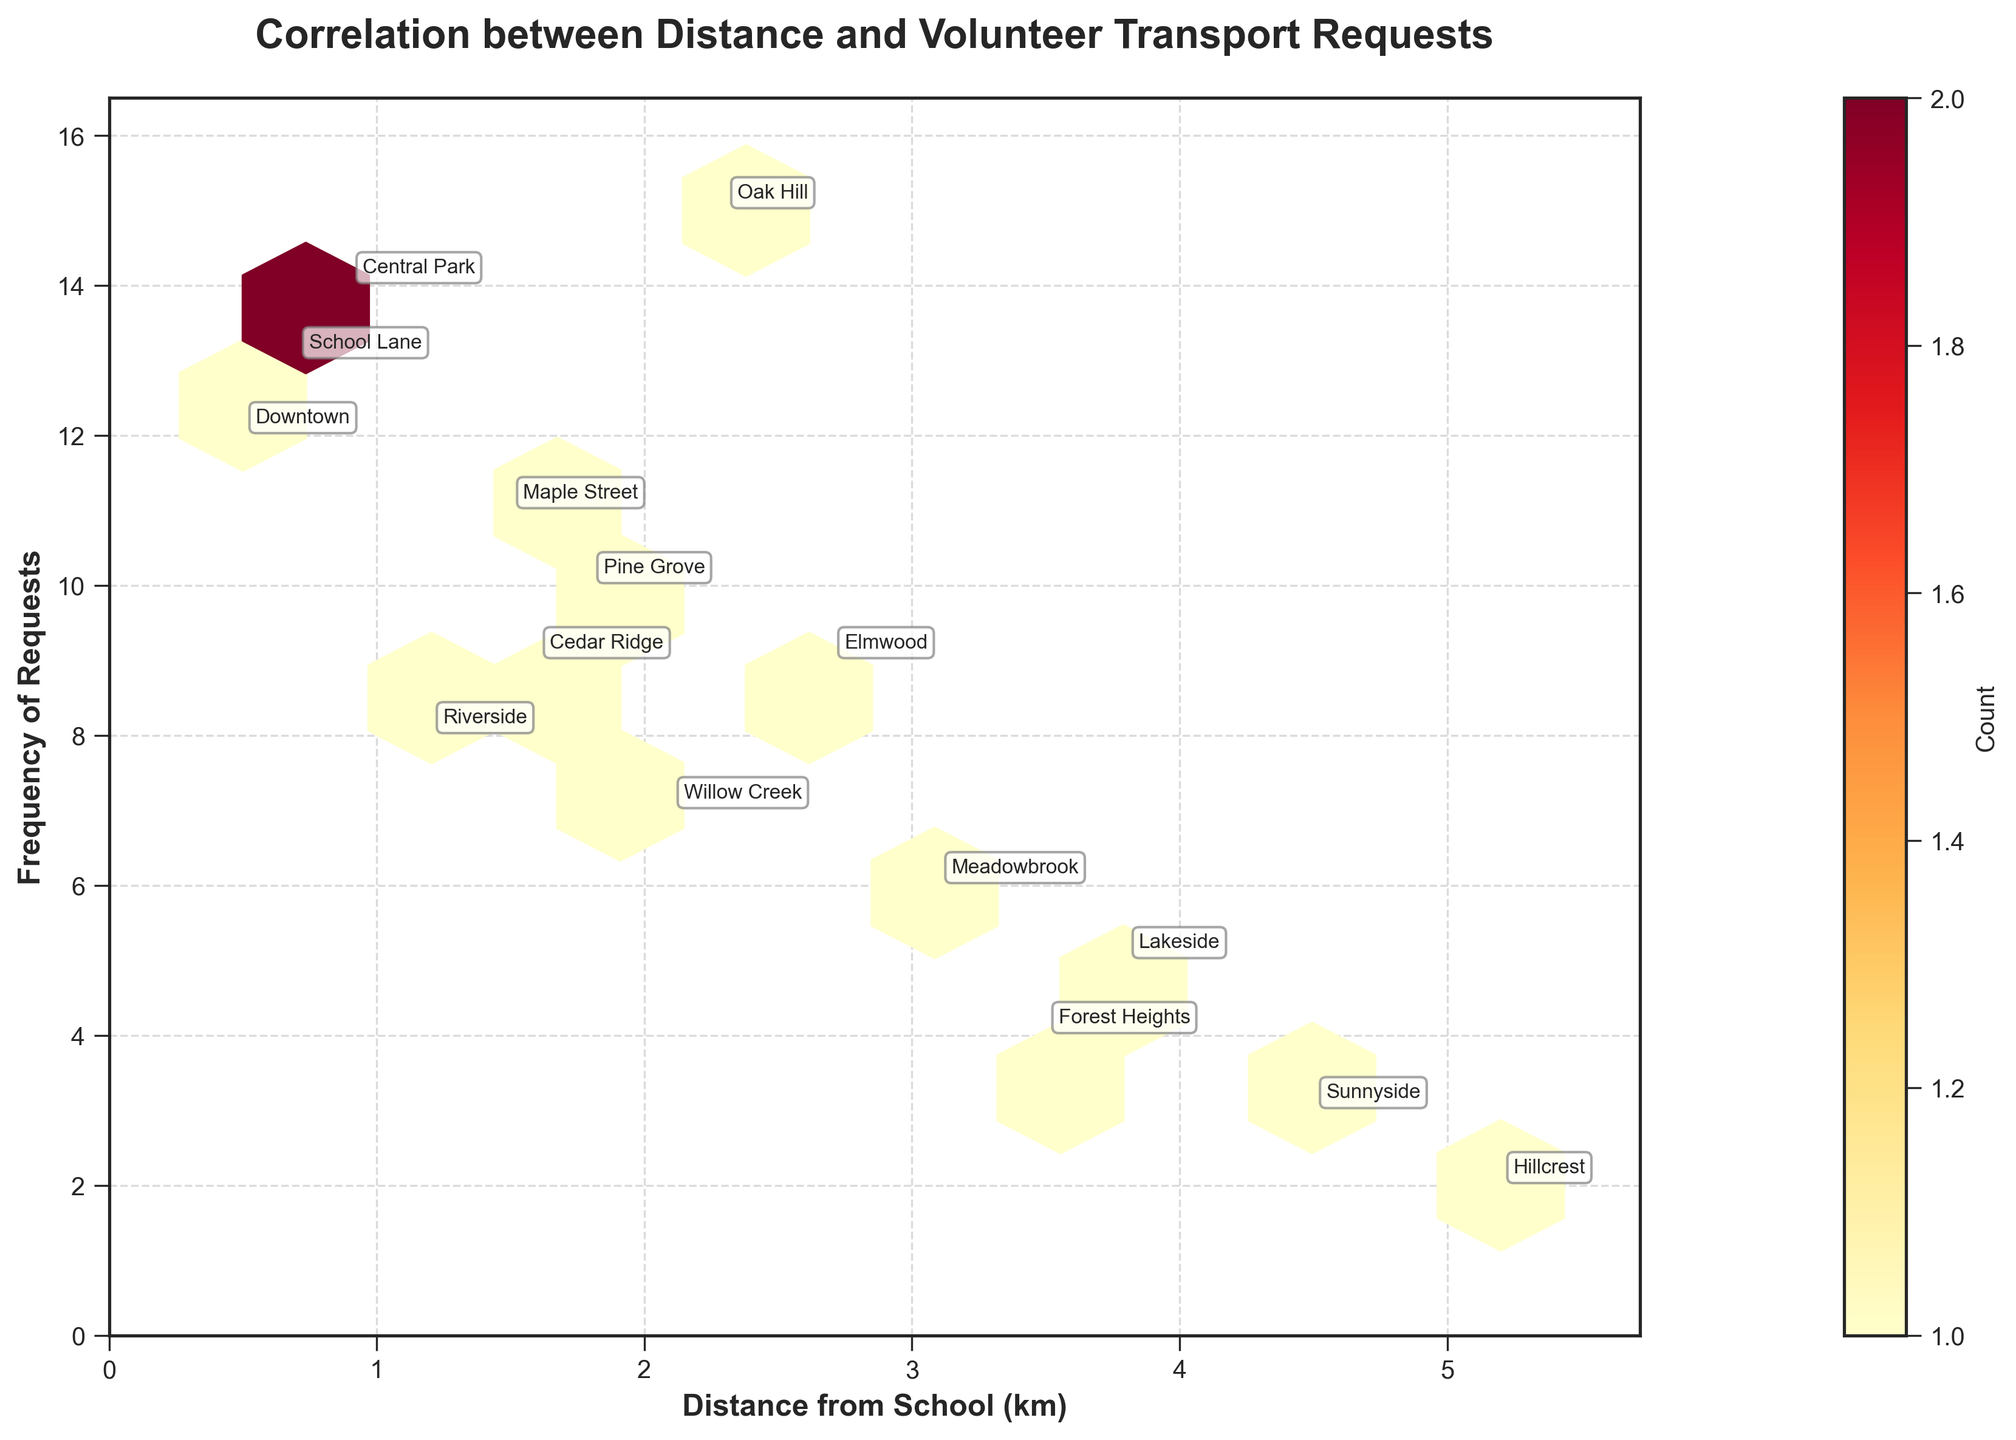What is the title of the plot? The title is located at the top of the plot and provides a summary of what the plot represents. In this case, the title is "Correlation between Distance and Volunteer Transport Requests".
Answer: Correlation between Distance and Volunteer Transport Requests How many data points are shown on the plot? Each data point on the plot represents a combination of distance and frequency. By counting these points, we can see there are 15 data points.
Answer: 15 Which distance category has the highest frequency of requests? By examining the y-axis (frequency) and looking for the highest value among data points, we notice that the highest frequency is 15, occurring at 2.3 km (Oak Hill).
Answer: 2.3 km (Oak Hill) Which area has a distance closest to 1 km with relatively high frequency? From the plot, identify areas close to 1 km on the x-axis and observe their frequency. Central Park (0.9 km) with a frequency of 14 stands out.
Answer: Central Park What is the frequency of requests at a distance of 3.5 km? Locate 3.5 km on the x-axis and find the corresponding frequency along the y-axis. The frequency for Forest Heights at this distance is 4.
Answer: 4 What is the combined frequency of requests for distances less than 1 km? Add the frequencies of areas with distances less than 1 km: Downtown (12) + Central Park (14) + School Lane (13) gives 39.
Answer: 39 Compare the frequency of requests at 1.2 km and 4.5 km. Which is higher? Examine the y-values for the points at 1.2 km and 4.5 km. The frequency is 8 at 1.2 km (Riverside) and 3 at 4.5 km (Sunnyside). Therefore, 1.2 km is higher.
Answer: 1.2 km What is the most common range of distances with high frequencies on the plot? By observing the plot, higher frequencies (>10 requests) are most common at distances less than 2 km. This includes Downtown, Central Park, School Lane, and Maple Street.
Answer: Less than 2 km Which area has the lowest frequency of requests and what is its distance? Identify the area with the frequency of 2, which is at the distance of 5.2 km. This corresponds to Hillcrest.
Answer: Hillcrest, 5.2 km 